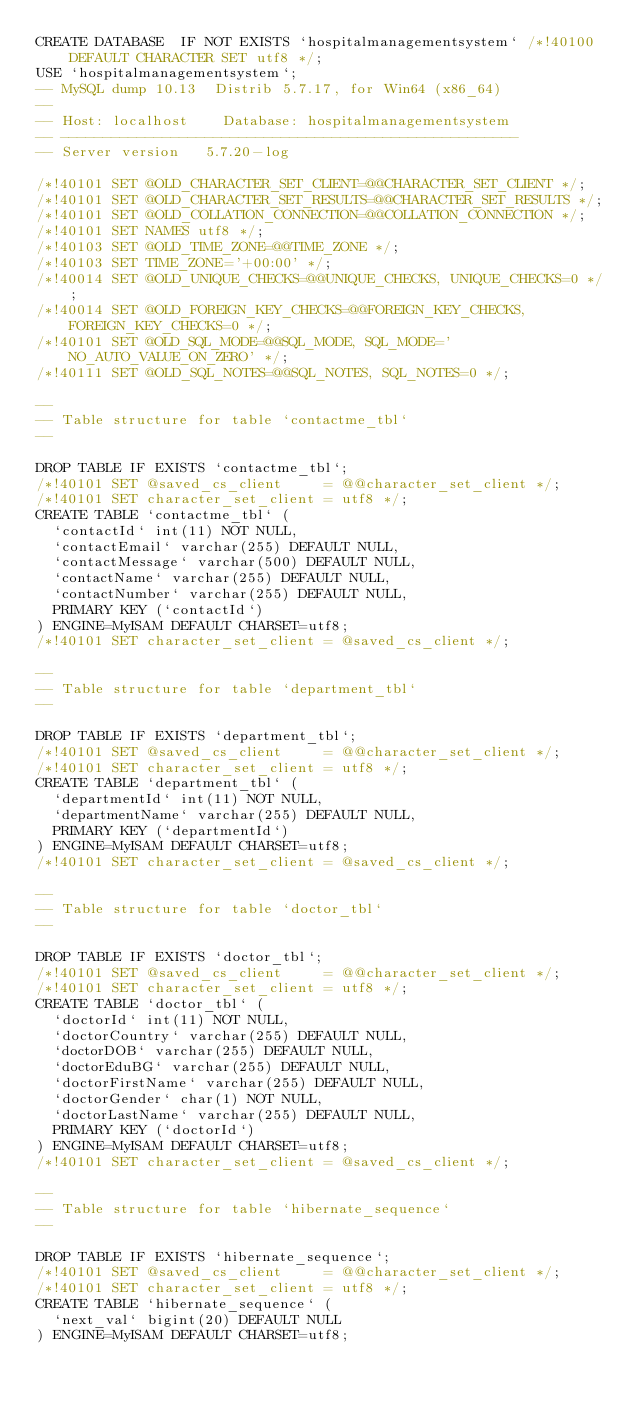<code> <loc_0><loc_0><loc_500><loc_500><_SQL_>CREATE DATABASE  IF NOT EXISTS `hospitalmanagementsystem` /*!40100 DEFAULT CHARACTER SET utf8 */;
USE `hospitalmanagementsystem`;
-- MySQL dump 10.13  Distrib 5.7.17, for Win64 (x86_64)
--
-- Host: localhost    Database: hospitalmanagementsystem
-- ------------------------------------------------------
-- Server version	5.7.20-log

/*!40101 SET @OLD_CHARACTER_SET_CLIENT=@@CHARACTER_SET_CLIENT */;
/*!40101 SET @OLD_CHARACTER_SET_RESULTS=@@CHARACTER_SET_RESULTS */;
/*!40101 SET @OLD_COLLATION_CONNECTION=@@COLLATION_CONNECTION */;
/*!40101 SET NAMES utf8 */;
/*!40103 SET @OLD_TIME_ZONE=@@TIME_ZONE */;
/*!40103 SET TIME_ZONE='+00:00' */;
/*!40014 SET @OLD_UNIQUE_CHECKS=@@UNIQUE_CHECKS, UNIQUE_CHECKS=0 */;
/*!40014 SET @OLD_FOREIGN_KEY_CHECKS=@@FOREIGN_KEY_CHECKS, FOREIGN_KEY_CHECKS=0 */;
/*!40101 SET @OLD_SQL_MODE=@@SQL_MODE, SQL_MODE='NO_AUTO_VALUE_ON_ZERO' */;
/*!40111 SET @OLD_SQL_NOTES=@@SQL_NOTES, SQL_NOTES=0 */;

--
-- Table structure for table `contactme_tbl`
--

DROP TABLE IF EXISTS `contactme_tbl`;
/*!40101 SET @saved_cs_client     = @@character_set_client */;
/*!40101 SET character_set_client = utf8 */;
CREATE TABLE `contactme_tbl` (
  `contactId` int(11) NOT NULL,
  `contactEmail` varchar(255) DEFAULT NULL,
  `contactMessage` varchar(500) DEFAULT NULL,
  `contactName` varchar(255) DEFAULT NULL,
  `contactNumber` varchar(255) DEFAULT NULL,
  PRIMARY KEY (`contactId`)
) ENGINE=MyISAM DEFAULT CHARSET=utf8;
/*!40101 SET character_set_client = @saved_cs_client */;

--
-- Table structure for table `department_tbl`
--

DROP TABLE IF EXISTS `department_tbl`;
/*!40101 SET @saved_cs_client     = @@character_set_client */;
/*!40101 SET character_set_client = utf8 */;
CREATE TABLE `department_tbl` (
  `departmentId` int(11) NOT NULL,
  `departmentName` varchar(255) DEFAULT NULL,
  PRIMARY KEY (`departmentId`)
) ENGINE=MyISAM DEFAULT CHARSET=utf8;
/*!40101 SET character_set_client = @saved_cs_client */;

--
-- Table structure for table `doctor_tbl`
--

DROP TABLE IF EXISTS `doctor_tbl`;
/*!40101 SET @saved_cs_client     = @@character_set_client */;
/*!40101 SET character_set_client = utf8 */;
CREATE TABLE `doctor_tbl` (
  `doctorId` int(11) NOT NULL,
  `doctorCountry` varchar(255) DEFAULT NULL,
  `doctorDOB` varchar(255) DEFAULT NULL,
  `doctorEduBG` varchar(255) DEFAULT NULL,
  `doctorFirstName` varchar(255) DEFAULT NULL,
  `doctorGender` char(1) NOT NULL,
  `doctorLastName` varchar(255) DEFAULT NULL,
  PRIMARY KEY (`doctorId`)
) ENGINE=MyISAM DEFAULT CHARSET=utf8;
/*!40101 SET character_set_client = @saved_cs_client */;

--
-- Table structure for table `hibernate_sequence`
--

DROP TABLE IF EXISTS `hibernate_sequence`;
/*!40101 SET @saved_cs_client     = @@character_set_client */;
/*!40101 SET character_set_client = utf8 */;
CREATE TABLE `hibernate_sequence` (
  `next_val` bigint(20) DEFAULT NULL
) ENGINE=MyISAM DEFAULT CHARSET=utf8;</code> 